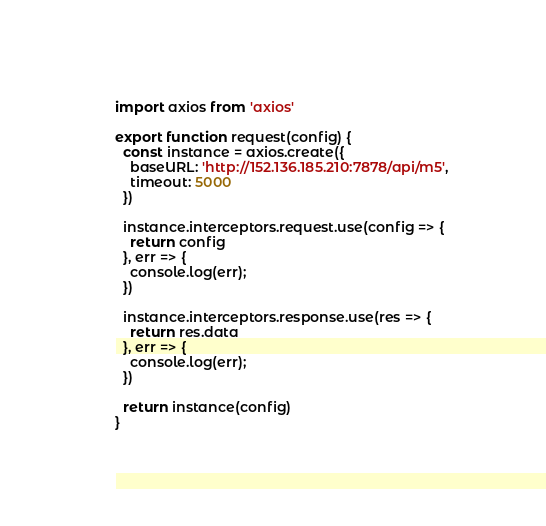<code> <loc_0><loc_0><loc_500><loc_500><_JavaScript_>import axios from 'axios'

export function request(config) {
  const instance = axios.create({
    baseURL: 'http://152.136.185.210:7878/api/m5',
    timeout: 5000
  })

  instance.interceptors.request.use(config => {
    return config
  }, err => {
    console.log(err);
  })

  instance.interceptors.response.use(res => {
    return res.data
  }, err => {
    console.log(err);
  })

  return instance(config)
}</code> 